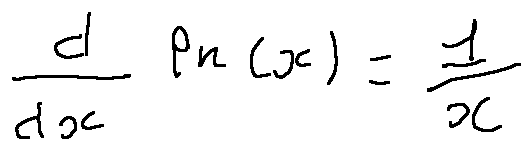<formula> <loc_0><loc_0><loc_500><loc_500>\frac { d } { d x } \ln ( x ) = \frac { 1 } { x }</formula> 